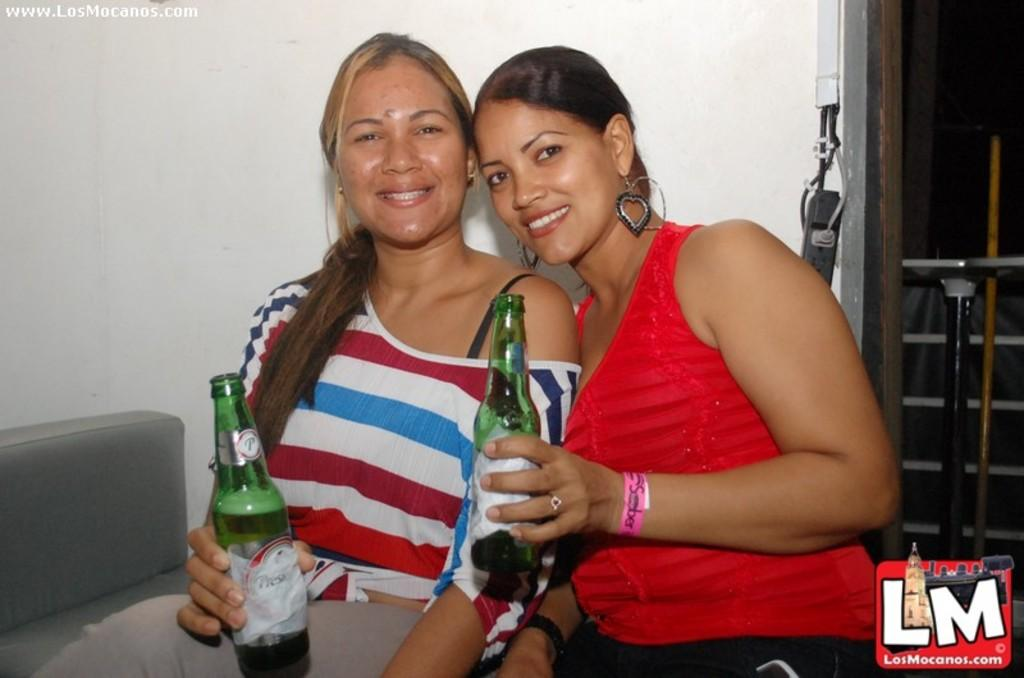How many people are in the image? There are two women in the image. What are the women doing in the image? The women are sitting together and catching a bottle. Can you describe their interaction in the image? The women are sitting together and working together to catch a bottle. What type of cactus can be seen in the background of the image? There is no cactus present in the image. How many waves can be seen crashing on the shore in the image? There is no shore or waves present in the image. 